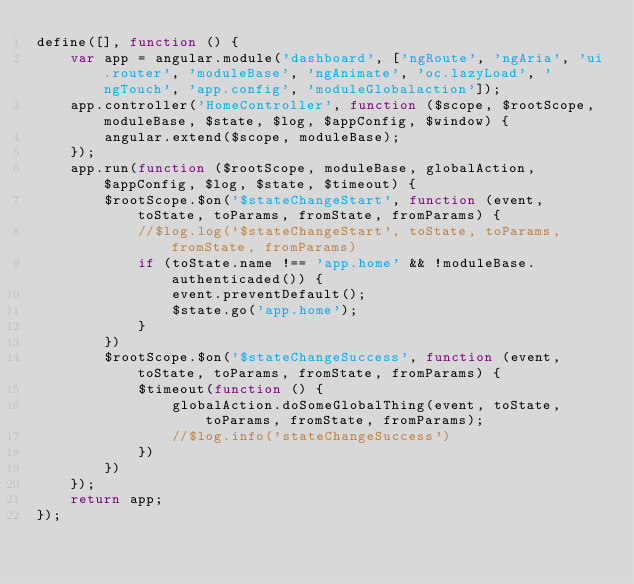<code> <loc_0><loc_0><loc_500><loc_500><_JavaScript_>define([], function () {
	var app = angular.module('dashboard', ['ngRoute', 'ngAria', 'ui.router', 'moduleBase', 'ngAnimate', 'oc.lazyLoad', 'ngTouch', 'app.config', 'moduleGlobalaction']);
	app.controller('HomeController', function ($scope, $rootScope, moduleBase, $state, $log, $appConfig, $window) {
		angular.extend($scope, moduleBase);
	});
	app.run(function ($rootScope, moduleBase, globalAction, $appConfig, $log, $state, $timeout) {
		$rootScope.$on('$stateChangeStart', function (event, toState, toParams, fromState, fromParams) {
			//$log.log('$stateChangeStart', toState, toParams, fromState, fromParams)
			if (toState.name !== 'app.home' && !moduleBase.authenticaded()) {
				event.preventDefault();
				$state.go('app.home');
			}
		})
		$rootScope.$on('$stateChangeSuccess', function (event, toState, toParams, fromState, fromParams) {
			$timeout(function () {
				globalAction.doSomeGlobalThing(event, toState, toParams, fromState, fromParams);
				//$log.info('stateChangeSuccess')
			})
		})
	});
	return app;
});
</code> 